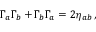<formula> <loc_0><loc_0><loc_500><loc_500>\Gamma _ { a } \Gamma _ { b } + \Gamma _ { b } \Gamma _ { a } = 2 \eta _ { a b } \, ,</formula> 